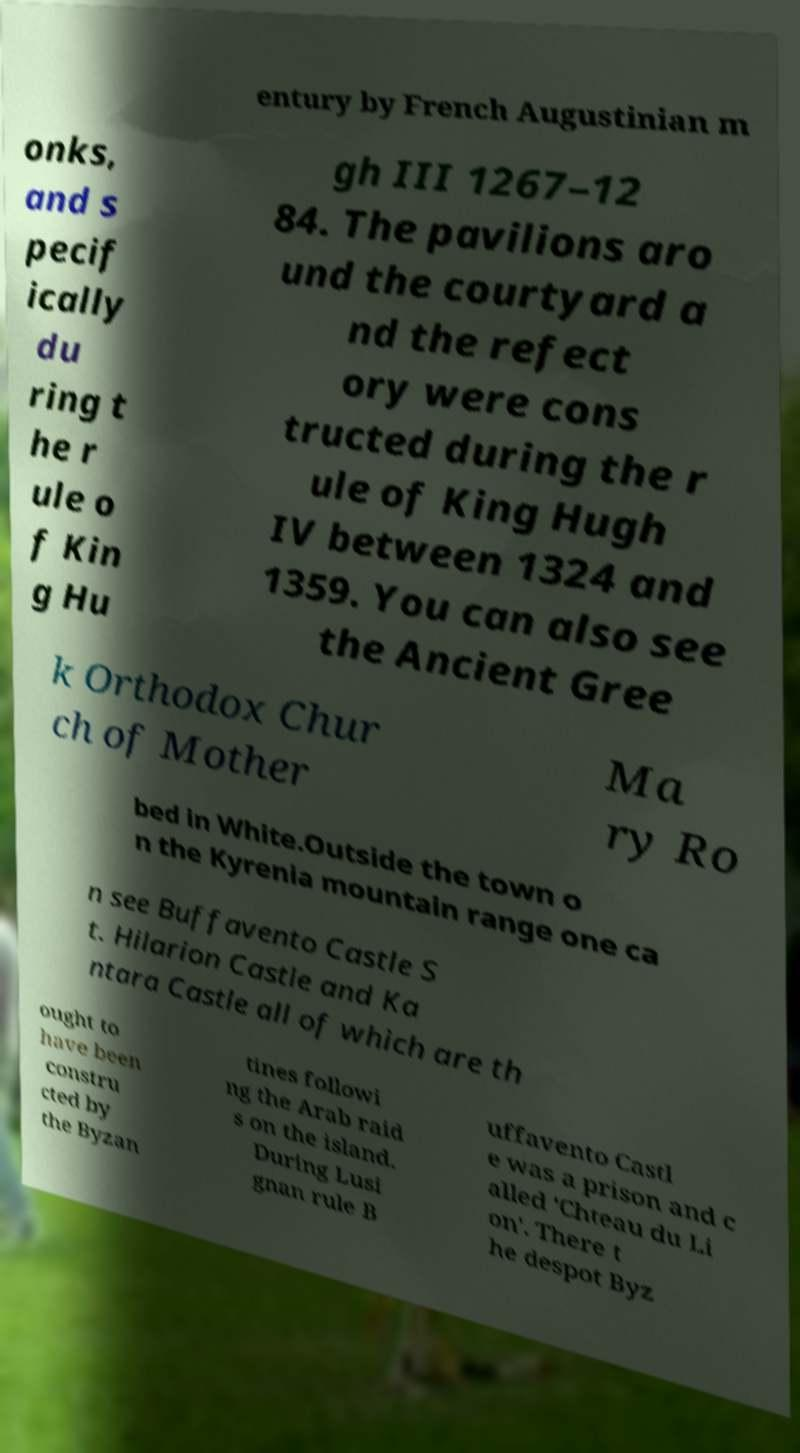Please read and relay the text visible in this image. What does it say? entury by French Augustinian m onks, and s pecif ically du ring t he r ule o f Kin g Hu gh III 1267–12 84. The pavilions aro und the courtyard a nd the refect ory were cons tructed during the r ule of King Hugh IV between 1324 and 1359. You can also see the Ancient Gree k Orthodox Chur ch of Mother Ma ry Ro bed in White.Outside the town o n the Kyrenia mountain range one ca n see Buffavento Castle S t. Hilarion Castle and Ka ntara Castle all of which are th ought to have been constru cted by the Byzan tines followi ng the Arab raid s on the island. During Lusi gnan rule B uffavento Castl e was a prison and c alled 'Chteau du Li on'. There t he despot Byz 